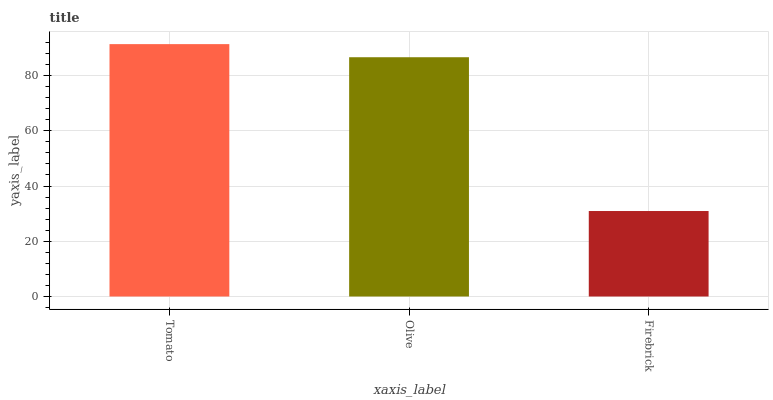Is Firebrick the minimum?
Answer yes or no. Yes. Is Tomato the maximum?
Answer yes or no. Yes. Is Olive the minimum?
Answer yes or no. No. Is Olive the maximum?
Answer yes or no. No. Is Tomato greater than Olive?
Answer yes or no. Yes. Is Olive less than Tomato?
Answer yes or no. Yes. Is Olive greater than Tomato?
Answer yes or no. No. Is Tomato less than Olive?
Answer yes or no. No. Is Olive the high median?
Answer yes or no. Yes. Is Olive the low median?
Answer yes or no. Yes. Is Tomato the high median?
Answer yes or no. No. Is Tomato the low median?
Answer yes or no. No. 